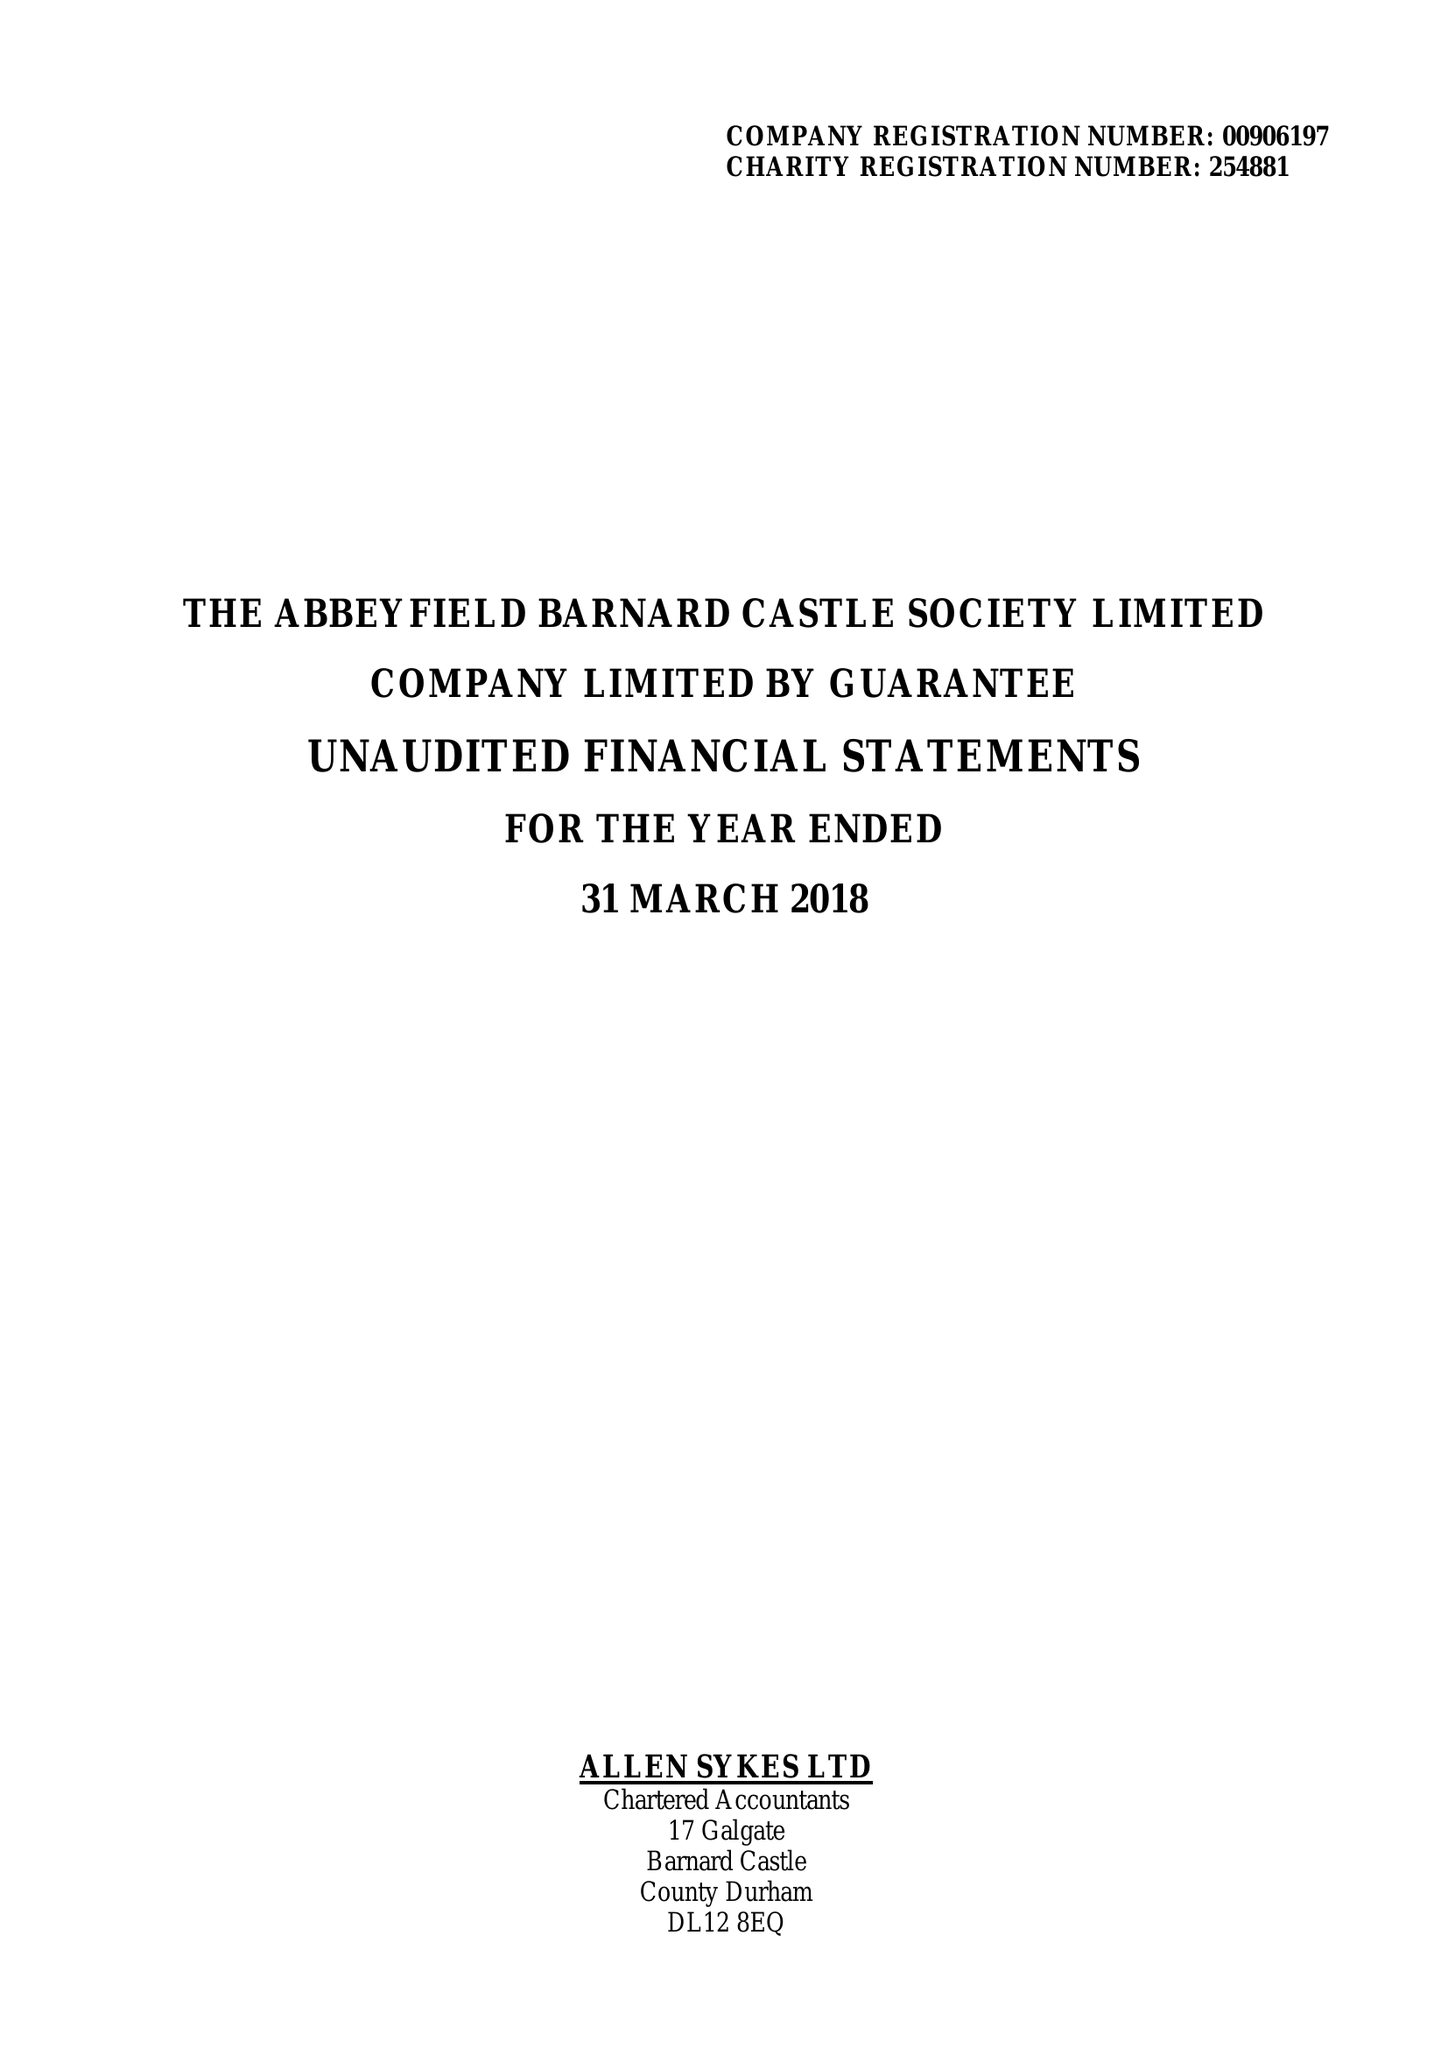What is the value for the address__postcode?
Answer the question using a single word or phrase. DL12 8BL 